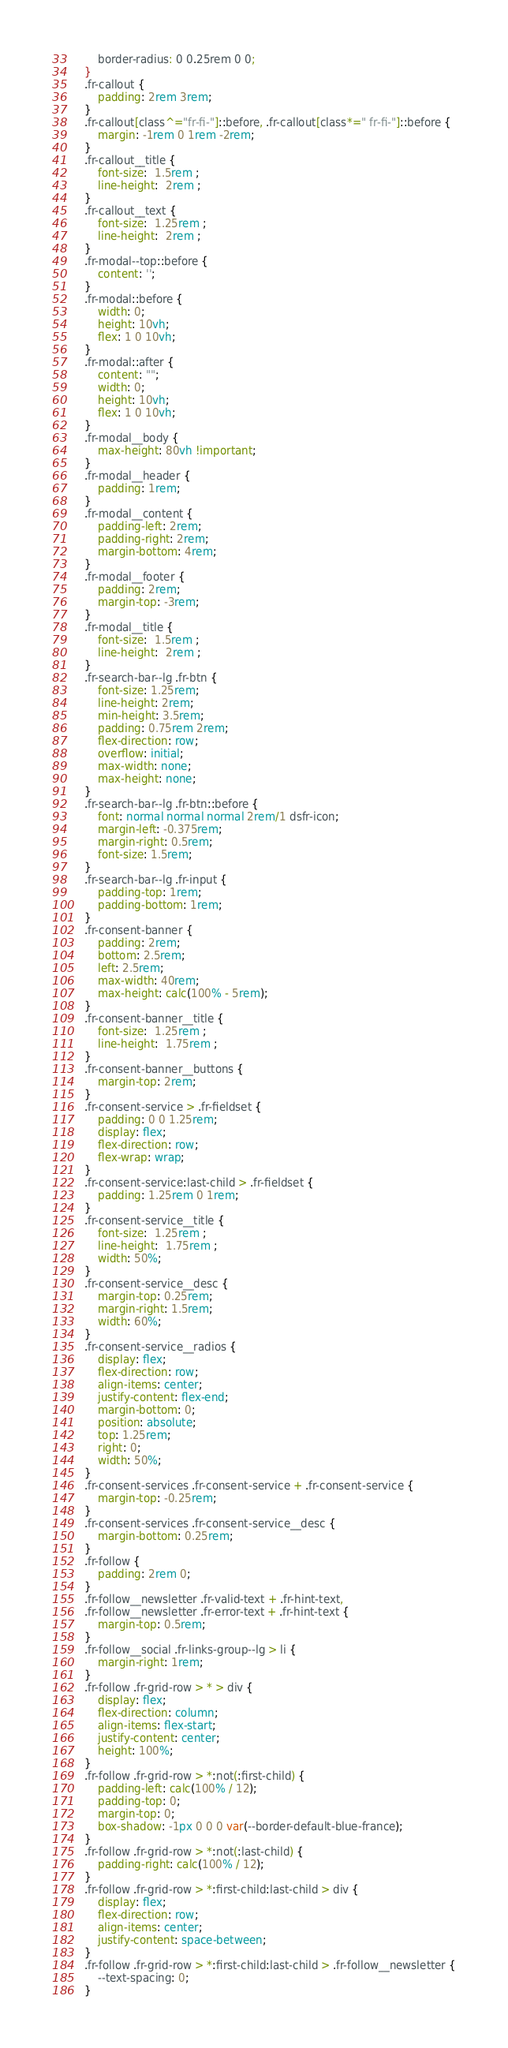<code> <loc_0><loc_0><loc_500><loc_500><_CSS_>        border-radius: 0 0.25rem 0 0;
    }
    .fr-callout {
        padding: 2rem 3rem;
    }
    .fr-callout[class^="fr-fi-"]::before, .fr-callout[class*=" fr-fi-"]::before {
        margin: -1rem 0 1rem -2rem;
    }
    .fr-callout__title {
        font-size:  1.5rem ;
        line-height:  2rem ;
    }
    .fr-callout__text {
        font-size:  1.25rem ;
        line-height:  2rem ;
    }
    .fr-modal--top::before {
        content: '';
    }
    .fr-modal::before {
        width: 0;
        height: 10vh;
        flex: 1 0 10vh;
    }
    .fr-modal::after {
        content: "";
        width: 0;
        height: 10vh;
        flex: 1 0 10vh;
    }
    .fr-modal__body {
        max-height: 80vh !important;
    }
    .fr-modal__header {
        padding: 1rem;
    }
    .fr-modal__content {
        padding-left: 2rem;
        padding-right: 2rem;
        margin-bottom: 4rem;
    }
    .fr-modal__footer {
        padding: 2rem;
        margin-top: -3rem;
    }
    .fr-modal__title {
        font-size:  1.5rem ;
        line-height:  2rem ;
    }
    .fr-search-bar--lg .fr-btn {
        font-size: 1.25rem;
        line-height: 2rem;
        min-height: 3.5rem;
        padding: 0.75rem 2rem;
        flex-direction: row;
        overflow: initial;
        max-width: none;
        max-height: none;
    }
    .fr-search-bar--lg .fr-btn::before {
        font: normal normal normal 2rem/1 dsfr-icon;
        margin-left: -0.375rem;
        margin-right: 0.5rem;
        font-size: 1.5rem;
    }
    .fr-search-bar--lg .fr-input {
        padding-top: 1rem;
        padding-bottom: 1rem;
    }
    .fr-consent-banner {
        padding: 2rem;
        bottom: 2.5rem;
        left: 2.5rem;
        max-width: 40rem;
        max-height: calc(100% - 5rem);
    }
    .fr-consent-banner__title {
        font-size:  1.25rem ;
        line-height:  1.75rem ;
    }
    .fr-consent-banner__buttons {
        margin-top: 2rem;
    }
    .fr-consent-service > .fr-fieldset {
        padding: 0 0 1.25rem;
        display: flex;
        flex-direction: row;
        flex-wrap: wrap;
    }
    .fr-consent-service:last-child > .fr-fieldset {
        padding: 1.25rem 0 1rem;
    }
    .fr-consent-service__title {
        font-size:  1.25rem ;
        line-height:  1.75rem ;
        width: 50%;
    }
    .fr-consent-service__desc {
        margin-top: 0.25rem;
        margin-right: 1.5rem;
        width: 60%;
    }
    .fr-consent-service__radios {
        display: flex;
        flex-direction: row;
        align-items: center;
        justify-content: flex-end;
        margin-bottom: 0;
        position: absolute;
        top: 1.25rem;
        right: 0;
        width: 50%;
    }
    .fr-consent-services .fr-consent-service + .fr-consent-service {
        margin-top: -0.25rem;
    }
    .fr-consent-services .fr-consent-service__desc {
        margin-bottom: 0.25rem;
    }
    .fr-follow {
        padding: 2rem 0;
    }
    .fr-follow__newsletter .fr-valid-text + .fr-hint-text,
    .fr-follow__newsletter .fr-error-text + .fr-hint-text {
        margin-top: 0.5rem;
    }
    .fr-follow__social .fr-links-group--lg > li {
        margin-right: 1rem;
    }
    .fr-follow .fr-grid-row > * > div {
        display: flex;
        flex-direction: column;
        align-items: flex-start;
        justify-content: center;
        height: 100%;
    }
    .fr-follow .fr-grid-row > *:not(:first-child) {
        padding-left: calc(100% / 12);
        padding-top: 0;
        margin-top: 0;
        box-shadow: -1px 0 0 0 var(--border-default-blue-france);
    }
    .fr-follow .fr-grid-row > *:not(:last-child) {
        padding-right: calc(100% / 12);
    }
    .fr-follow .fr-grid-row > *:first-child:last-child > div {
        display: flex;
        flex-direction: row;
        align-items: center;
        justify-content: space-between;
    }
    .fr-follow .fr-grid-row > *:first-child:last-child > .fr-follow__newsletter {
        --text-spacing: 0;
    }</code> 